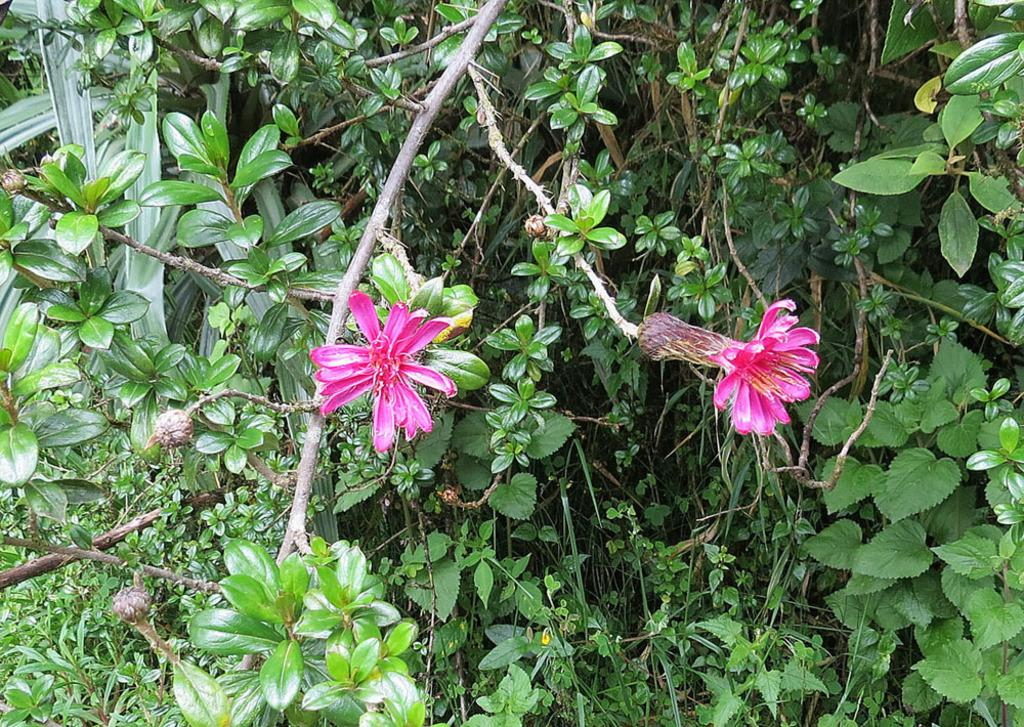Where was the image taken? The image was clicked outside. What can be seen in the foreground of the image? There are flowers and green leaves of plants in the foreground of the image. What other plant elements are visible in the image? There are branches and stems visible in the image. What type of drawer can be seen in the image? There is no drawer present in the image; it features flowers, green leaves, branches, and stems. 